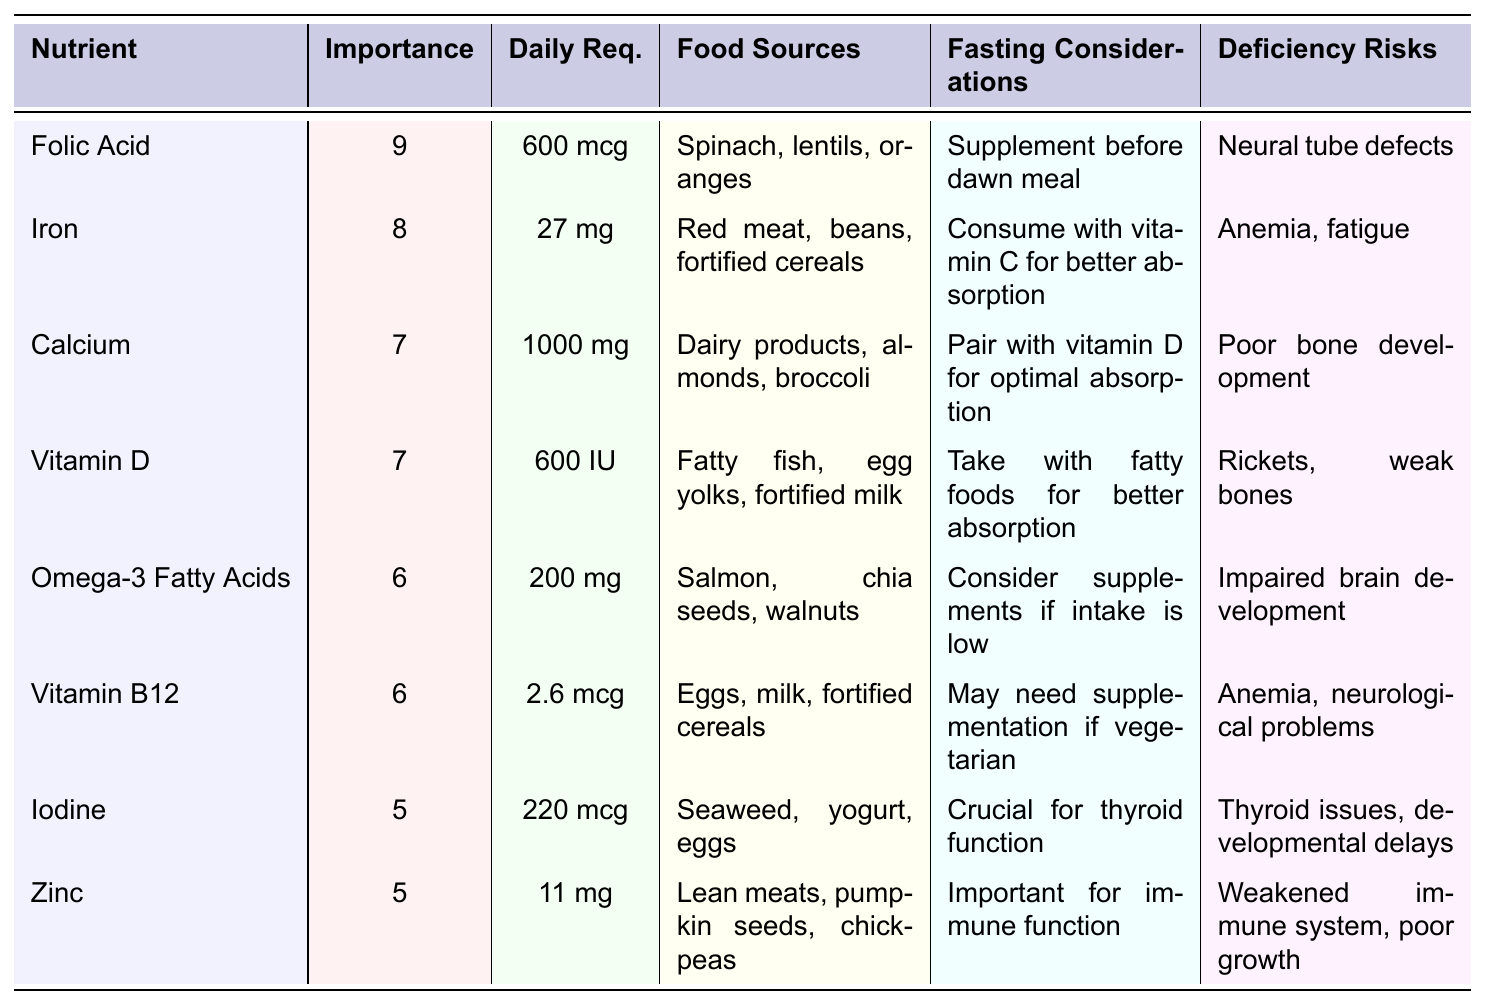What is the daily requirement of Folic Acid? The table lists the daily requirement for Folic Acid as 600 mcg.
Answer: 600 mcg Which nutrient has the highest importance score? Among the nutrients listed, Folic Acid has the highest importance score of 9.
Answer: Folic Acid How many mg of Calcium is required daily? The daily requirement for Calcium is specified as 1000 mg in the table.
Answer: 1000 mg Is it true that Vitamin B12 is important for preventing anemia? The table states that deficiency in Vitamin B12 can lead to anemia, which indicates it is indeed important for preventing this condition.
Answer: Yes What food source is recommended for obtaining Omega-3 Fatty Acids? The table indicates that Omega-3 Fatty Acids can be sourced from salmon, chia seeds, and walnuts.
Answer: Salmon, chia seeds, walnuts What is the combined daily requirement for Iron and Vitamin D? The daily requirement for Iron is 27 mg and for Vitamin D is 600 IU. Combined, this totals 27 mg + 600 IU (values cannot be directly added due to different units, so the answer reflects understanding of their individual requirements).
Answer: 27 mg (Iron) + 600 IU (Vitamin D) Which nutrient requires supplementation if a person is vegetarian? The table mentions that Vitamin B12 may require supplementation if one follows a vegetarian diet.
Answer: Vitamin B12 How does Calcium absorption relate to Vitamin D according to the table? The table states that Calcium should be paired with Vitamin D for optimal absorption. Hence, their absorption is interdependent.
Answer: They should be paired for optimal absorption List the nutrients that help in fetal brain development based on the table. The nutrients listed are Folic Acid and Omega-3 Fatty Acids, as both are related to brain development or neural health per their deficiency risks.
Answer: Folic Acid, Omega-3 Fatty Acids What is the deficiency risk associated with Zinc? The table notes that a deficiency in Zinc can weaken the immune system and hinder growth.
Answer: Weakened immune system, poor growth How many nutrients have an importance score of 6 or higher? The table shows 6 nutrients scoring 6 or higher (Folic Acid, Iron, Calcium, Vitamin D, Omega-3 Fatty Acids, and Vitamin B12). This is determined by counting those with scores of 6 or above.
Answer: 6 nutrients What food sources should be consumed with Iron for better absorption? The table advises consuming Iron with Vitamin C to enhance its absorption.
Answer: Vitamin C rich foods What is the importance of Iodine during pregnancy as per the table? According to the table, Iodine is crucial for thyroid function, which is important for overall fetal development.
Answer: Crucial for thyroid function 